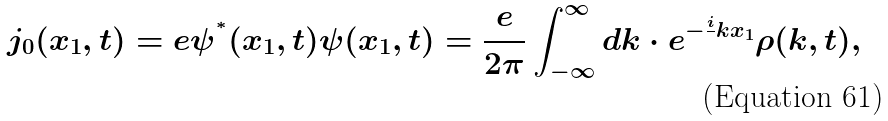<formula> <loc_0><loc_0><loc_500><loc_500>j _ { 0 } ( x _ { 1 } , t ) = e { \psi } ^ { ^ { * } } ( x _ { 1 } , t ) { \psi } ( x _ { 1 } , t ) = \frac { e } { 2 \pi } \int _ { - \infty } ^ { \infty } d k \cdot e ^ { - \frac { i } { } k x _ { 1 } } { \rho } ( k , t ) ,</formula> 